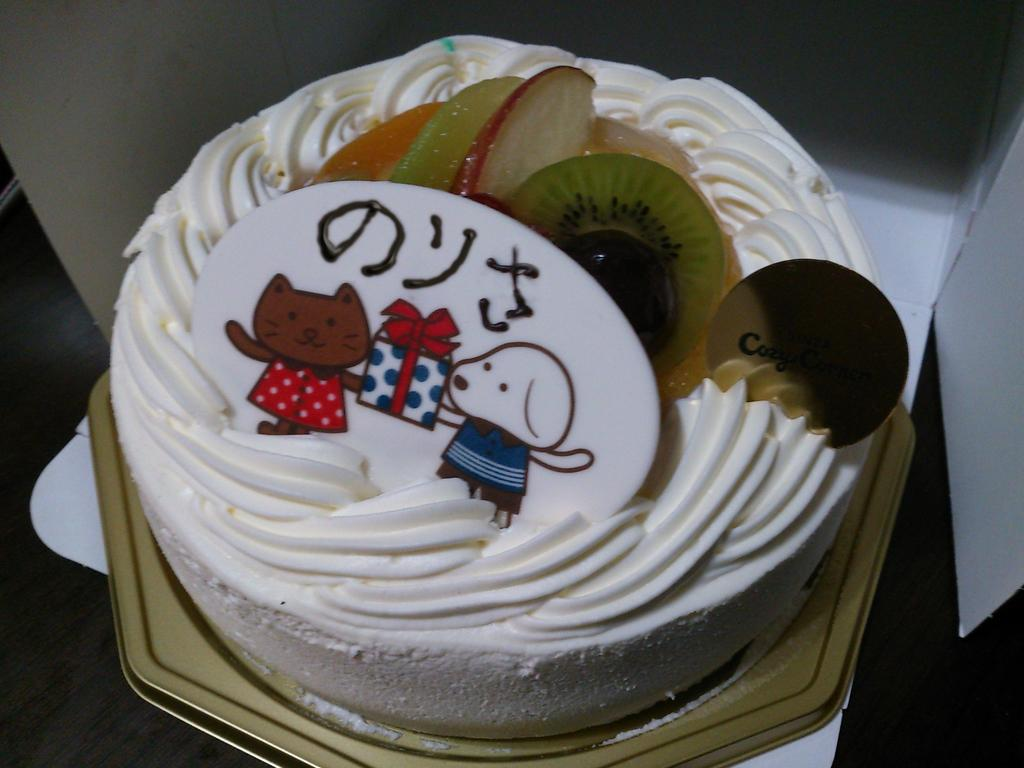What is on the plate that is visible in the image? The plate has a cake on it. How is the cake being stored or protected in the image? The cake is kept in a box. What type of group is performing on the cake in the image? There is no group performing on the cake in the image; it is simply a cake on a plate inside a box. 